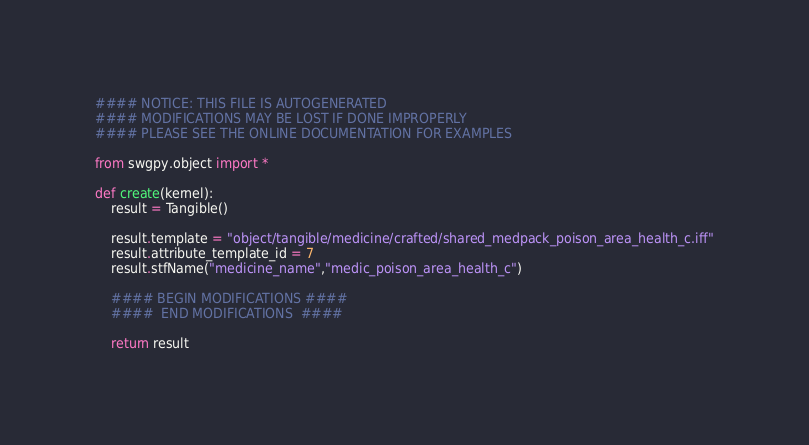<code> <loc_0><loc_0><loc_500><loc_500><_Python_>#### NOTICE: THIS FILE IS AUTOGENERATED
#### MODIFICATIONS MAY BE LOST IF DONE IMPROPERLY
#### PLEASE SEE THE ONLINE DOCUMENTATION FOR EXAMPLES

from swgpy.object import *	

def create(kernel):
	result = Tangible()

	result.template = "object/tangible/medicine/crafted/shared_medpack_poison_area_health_c.iff"
	result.attribute_template_id = 7
	result.stfName("medicine_name","medic_poison_area_health_c")		
	
	#### BEGIN MODIFICATIONS ####
	####  END MODIFICATIONS  ####
	
	return result</code> 